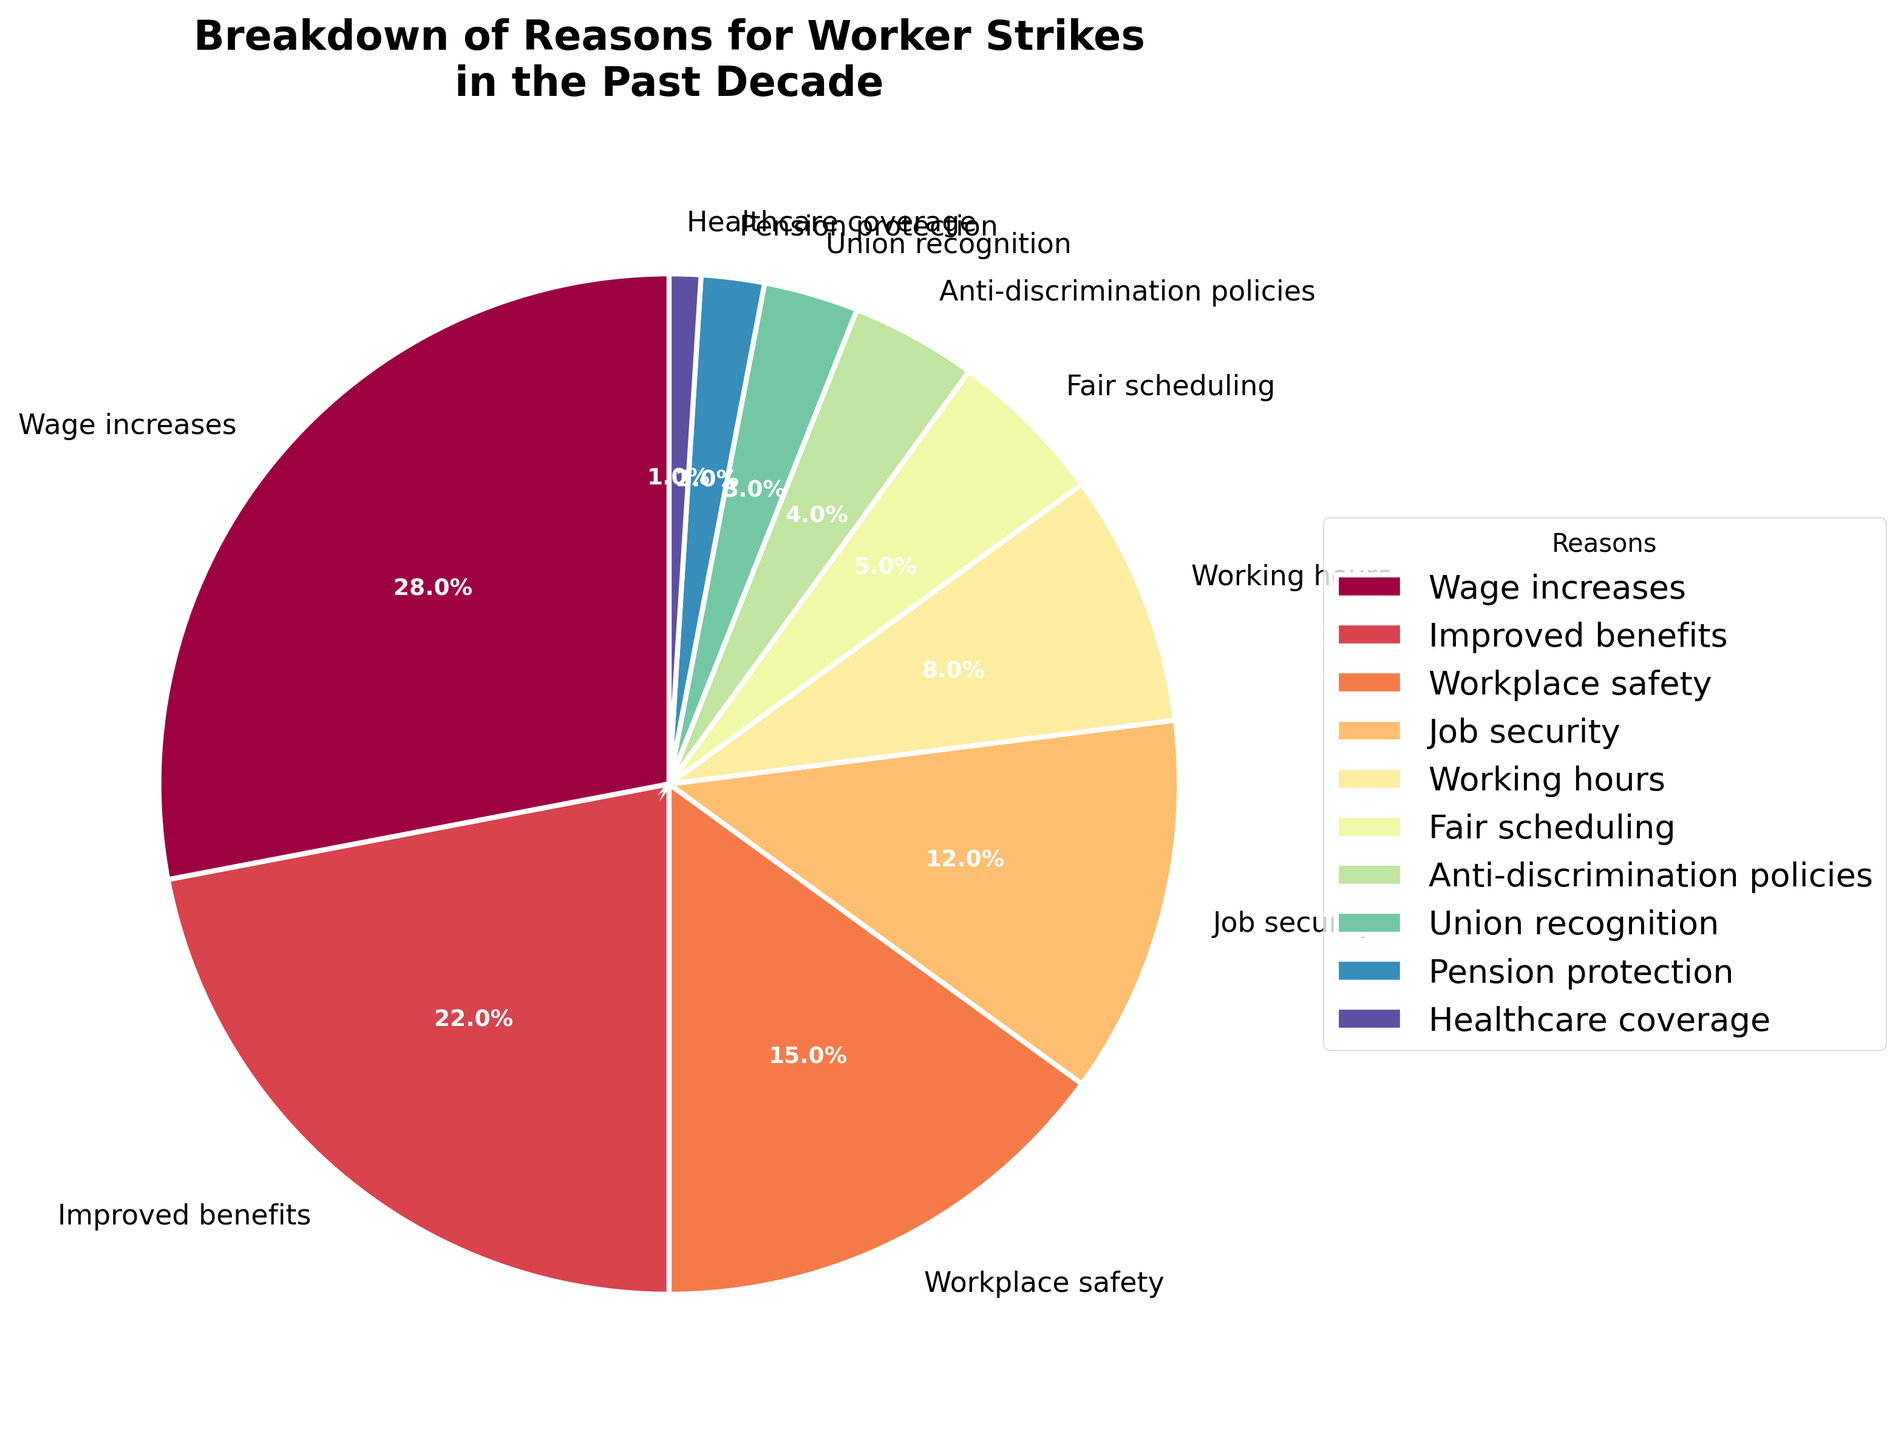What is the percentage of strikes caused by demand for wage increases? The chart shows a pie slice labeled "Wage increases," which constitutes 28% of the total reasons for worker strikes.
Answer: 28% Which reason for strikes has the lowest percentage? The smallest slice might be identified as "Healthcare coverage," which accounts for 1% of strikes.
Answer: Healthcare coverage What is the combined percentage of strikes due to improved benefits and workplace safety? The pie chart shows improved benefits at 22% and workplace safety at 15%. Adding these percentages together gives 22% + 15% = 37%.
Answer: 37% How does the percentage of strikes due to job security compare to those due to improved benefits? The pie chart shows job security at 12% and improved benefits at 22%. Comparatively, job security is 10 percentage points less than improved benefits (22% - 12% = 10%).
Answer: 10% less What are the top three reasons for worker strikes based on the chart? The largest slices in the pie chart represent wage increases (28%), improved benefits (22%), and workplace safety (15%).
Answer: Wage increases, improved benefits, workplace safety Which two categories combined total less than 10%? The pie chart shows categories with smaller percentages, such as union recognition (3%) and pension protection (2%). Their combined total is 3% + 2% = 5%, which is less than 10%.
Answer: Union recognition and pension protection What is the percentage difference between strikes for working hours and fair scheduling? The visual shows working hours at 8% and fair scheduling at 5%. The difference is 8% - 5% = 3%.
Answer: 3% Which category related to work-life balance accounts for a higher percentage, working hours or fair scheduling? The pie chart indicates that working hours are at 8%, while fair scheduling is at 5%. Thus, working hours account for a higher percentage.
Answer: Working hours What is the total percentage of strikes for reasons related to benefits exceeding 20%? List the reasons involved. The segments for improved benefits (22%) and pension protection (2%), when combined, exceed 20%. Improved benefits (22%) alone also exceed 20%. Therefore, improved benefits are the primary reason.
Answer: Improved benefits 